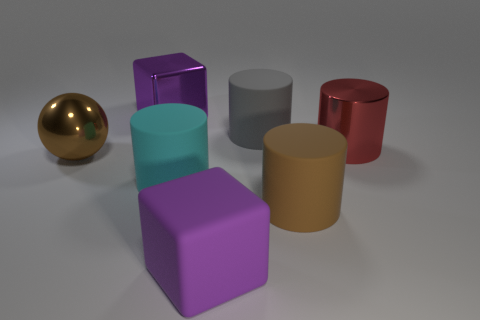Are there more big brown matte objects that are behind the gray cylinder than cylinders behind the big cyan object?
Your answer should be very brief. No. What color is the big thing that is to the left of the big purple cube that is behind the metal cylinder?
Offer a terse response. Brown. Is there a big metal object that has the same color as the metallic ball?
Your answer should be compact. No. How big is the rubber cylinder that is behind the big brown metal ball that is behind the large brown object that is right of the big sphere?
Offer a very short reply. Large. The big red shiny thing is what shape?
Give a very brief answer. Cylinder. The matte block that is the same color as the shiny cube is what size?
Your answer should be very brief. Large. There is a big metallic block that is left of the big purple rubber cube; how many large gray objects are to the left of it?
Your response must be concise. 0. What number of other objects are there of the same material as the ball?
Offer a very short reply. 2. Is the big red thing in front of the big gray rubber cylinder made of the same material as the large purple object that is in front of the red object?
Your response must be concise. No. Is there anything else that has the same shape as the brown metal thing?
Provide a short and direct response. No. 